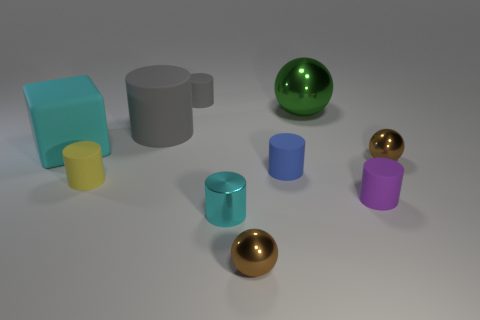How many metallic things are small cyan objects or big things?
Offer a terse response. 2. The metallic object that is the same size as the cyan matte block is what shape?
Offer a terse response. Sphere. How many things are either tiny shiny objects that are behind the small yellow object or matte cylinders behind the purple rubber thing?
Give a very brief answer. 5. There is a gray object that is the same size as the green shiny ball; what material is it?
Provide a succinct answer. Rubber. How many other things are there of the same material as the big cyan block?
Give a very brief answer. 5. Are there the same number of metallic cylinders to the left of the big cyan block and large green things that are in front of the tiny gray cylinder?
Your response must be concise. No. What number of green things are cylinders or small matte cylinders?
Give a very brief answer. 0. Do the small shiny cylinder and the small ball that is on the right side of the tiny purple cylinder have the same color?
Your response must be concise. No. What number of other objects are there of the same color as the big block?
Provide a short and direct response. 1. Are there fewer small blue objects than large red shiny balls?
Make the answer very short. No. 